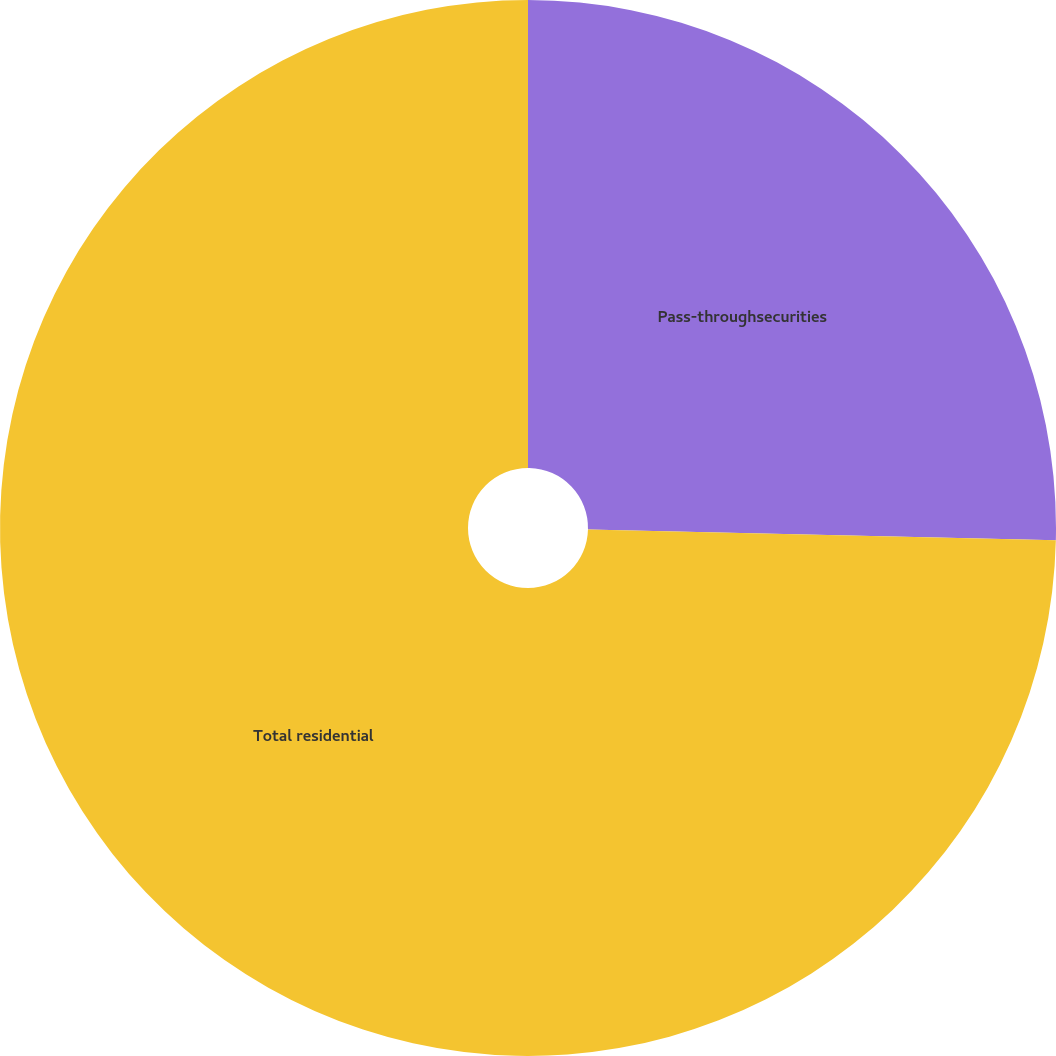Convert chart to OTSL. <chart><loc_0><loc_0><loc_500><loc_500><pie_chart><fcel>Pass-throughsecurities<fcel>Total residential<nl><fcel>25.37%<fcel>74.63%<nl></chart> 